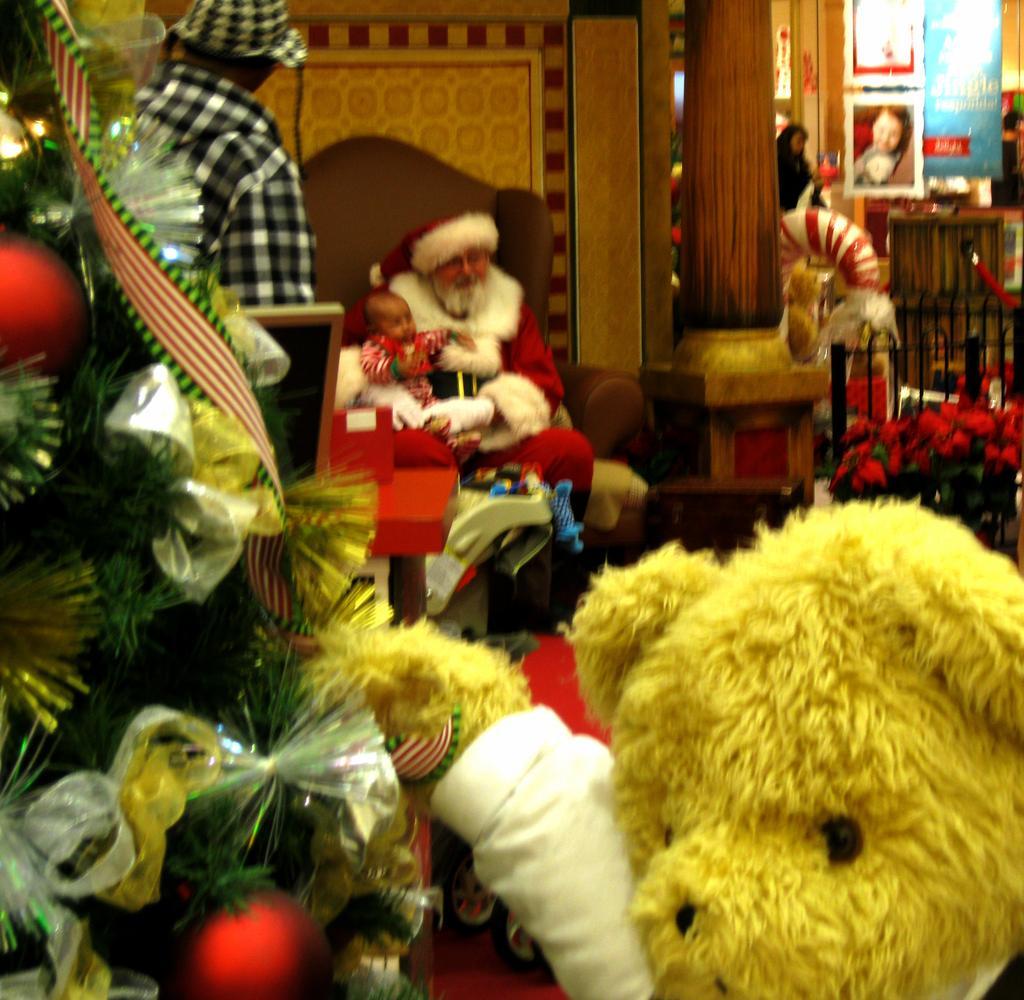Could you give a brief overview of what you see in this image? In the center of the image there is a santa and kid sitting on the chair. On the left side of the image we can see Christmas tree and person. At the bottom of the image we can see teddy bear and toys. In the background we can see wall, pillar, person, fencing and advertisement. 